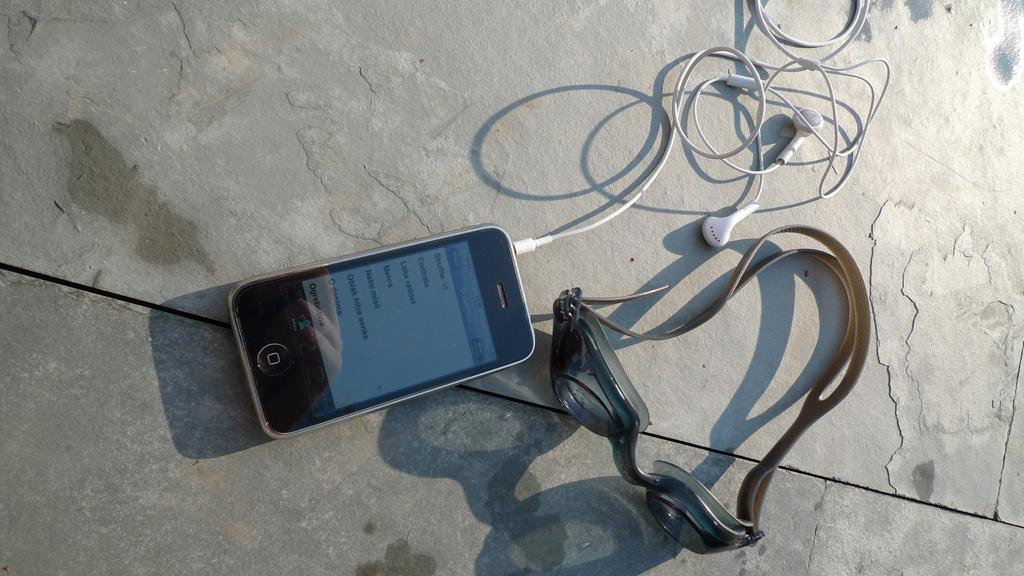<image>
Relay a brief, clear account of the picture shown. An iPhone with a playlist on Shuffle next to a pair of swim goggles. 